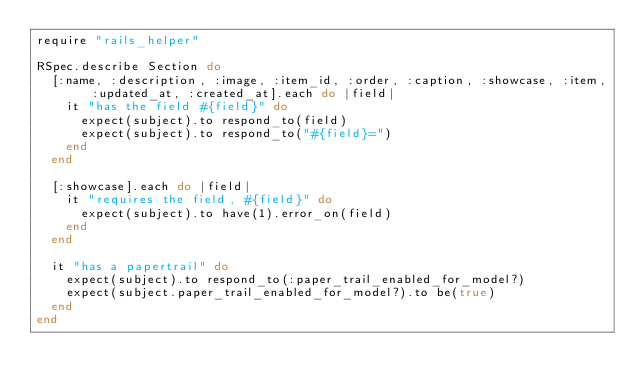Convert code to text. <code><loc_0><loc_0><loc_500><loc_500><_Ruby_>require "rails_helper"

RSpec.describe Section do
  [:name, :description, :image, :item_id, :order, :caption, :showcase, :item, :updated_at, :created_at].each do |field|
    it "has the field #{field}" do
      expect(subject).to respond_to(field)
      expect(subject).to respond_to("#{field}=")
    end
  end

  [:showcase].each do |field|
    it "requires the field, #{field}" do
      expect(subject).to have(1).error_on(field)
    end
  end

  it "has a papertrail" do
    expect(subject).to respond_to(:paper_trail_enabled_for_model?)
    expect(subject.paper_trail_enabled_for_model?).to be(true)
  end
end
</code> 